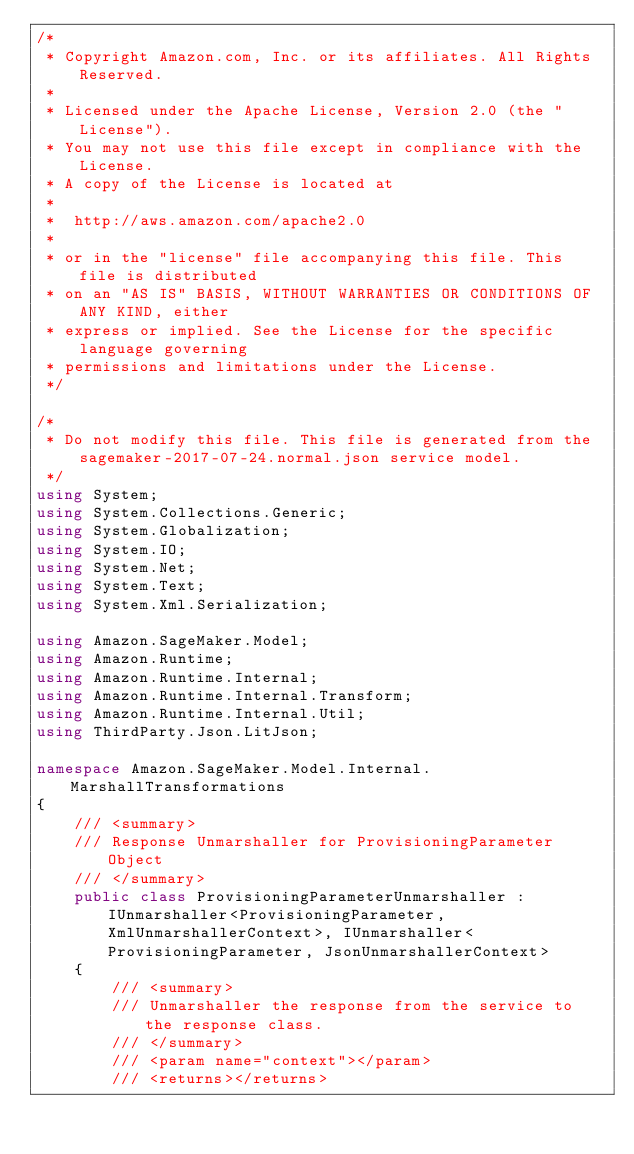Convert code to text. <code><loc_0><loc_0><loc_500><loc_500><_C#_>/*
 * Copyright Amazon.com, Inc. or its affiliates. All Rights Reserved.
 * 
 * Licensed under the Apache License, Version 2.0 (the "License").
 * You may not use this file except in compliance with the License.
 * A copy of the License is located at
 * 
 *  http://aws.amazon.com/apache2.0
 * 
 * or in the "license" file accompanying this file. This file is distributed
 * on an "AS IS" BASIS, WITHOUT WARRANTIES OR CONDITIONS OF ANY KIND, either
 * express or implied. See the License for the specific language governing
 * permissions and limitations under the License.
 */

/*
 * Do not modify this file. This file is generated from the sagemaker-2017-07-24.normal.json service model.
 */
using System;
using System.Collections.Generic;
using System.Globalization;
using System.IO;
using System.Net;
using System.Text;
using System.Xml.Serialization;

using Amazon.SageMaker.Model;
using Amazon.Runtime;
using Amazon.Runtime.Internal;
using Amazon.Runtime.Internal.Transform;
using Amazon.Runtime.Internal.Util;
using ThirdParty.Json.LitJson;

namespace Amazon.SageMaker.Model.Internal.MarshallTransformations
{
    /// <summary>
    /// Response Unmarshaller for ProvisioningParameter Object
    /// </summary>  
    public class ProvisioningParameterUnmarshaller : IUnmarshaller<ProvisioningParameter, XmlUnmarshallerContext>, IUnmarshaller<ProvisioningParameter, JsonUnmarshallerContext>
    {
        /// <summary>
        /// Unmarshaller the response from the service to the response class.
        /// </summary>  
        /// <param name="context"></param>
        /// <returns></returns></code> 